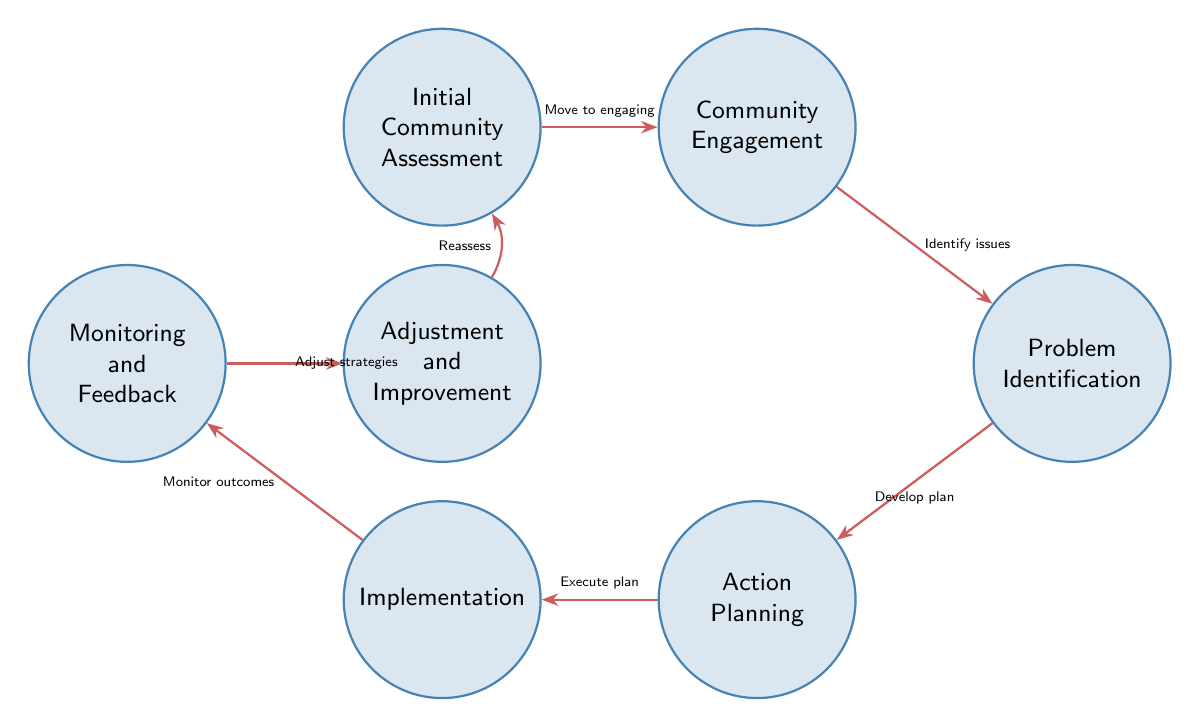What is the first state in the diagram? The initial state in the diagram is labeled as "Initial Community Assessment." This is indicated at the top of the state sequence and is the starting point for the finite state machine.
Answer: Initial Community Assessment How many total states are there in the system? The diagram presents a total of seven states, which are listed individually and are visually distinct from each other in the diagram.
Answer: 7 What action follows "Community Engagement"? After "Community Engagement," the next state according to the diagram is "Problem Identification." This is indicated by the directed edge leading from "Community Engagement" to "Problem Identification."
Answer: Problem Identification What is the last state in this interaction model? The last state in the model is "Adjustment and Improvement," evidenced by its position in the sequence and the directed edge that loops back to the "Initial Community Assessment" state.
Answer: Adjustment and Improvement Which state does "Action Planning" lead to? "Action Planning" leads to "Implementation," as shown in the diagram where the transition from "Action Planning" points to "Implementation."
Answer: Implementation How does "Monitoring and Feedback" influence the process? "Monitoring and Feedback" influences the process by adjusting strategies based on community feedback, as indicated by the directed edge leading to "Adjustment and Improvement."
Answer: Adjust strategies If community feedback is gathered, what is the next state? If community feedback is gathered in the "Monitoring and Feedback" state, the next step is to proceed to "Adjustment and Improvement," following the transition indicated in the diagram.
Answer: Adjustment and Improvement Which two states are connected by the action "Develop plan"? The action "Develop plan" connects the states "Problem Identification" and "Action Planning," as shown in the diagram where the edge directly links these two states.
Answer: Problem Identification and Action Planning 